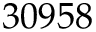Convert formula to latex. <formula><loc_0><loc_0><loc_500><loc_500>3 0 9 5 8</formula> 